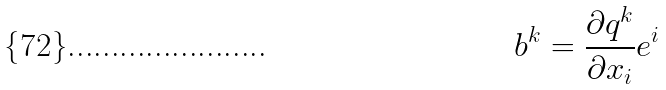Convert formula to latex. <formula><loc_0><loc_0><loc_500><loc_500>b ^ { k } = \frac { \partial q ^ { k } } { \partial x _ { i } } e ^ { i }</formula> 